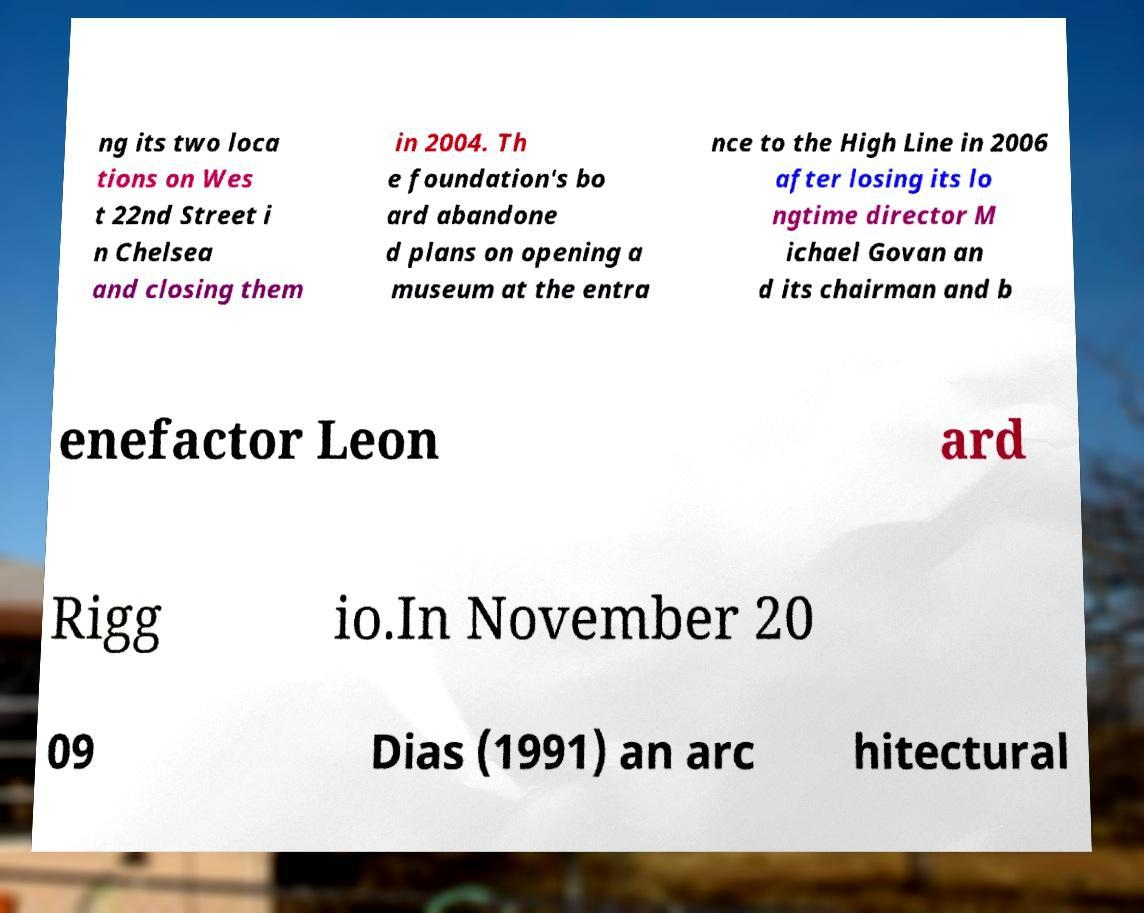What messages or text are displayed in this image? I need them in a readable, typed format. ng its two loca tions on Wes t 22nd Street i n Chelsea and closing them in 2004. Th e foundation's bo ard abandone d plans on opening a museum at the entra nce to the High Line in 2006 after losing its lo ngtime director M ichael Govan an d its chairman and b enefactor Leon ard Rigg io.In November 20 09 Dias (1991) an arc hitectural 